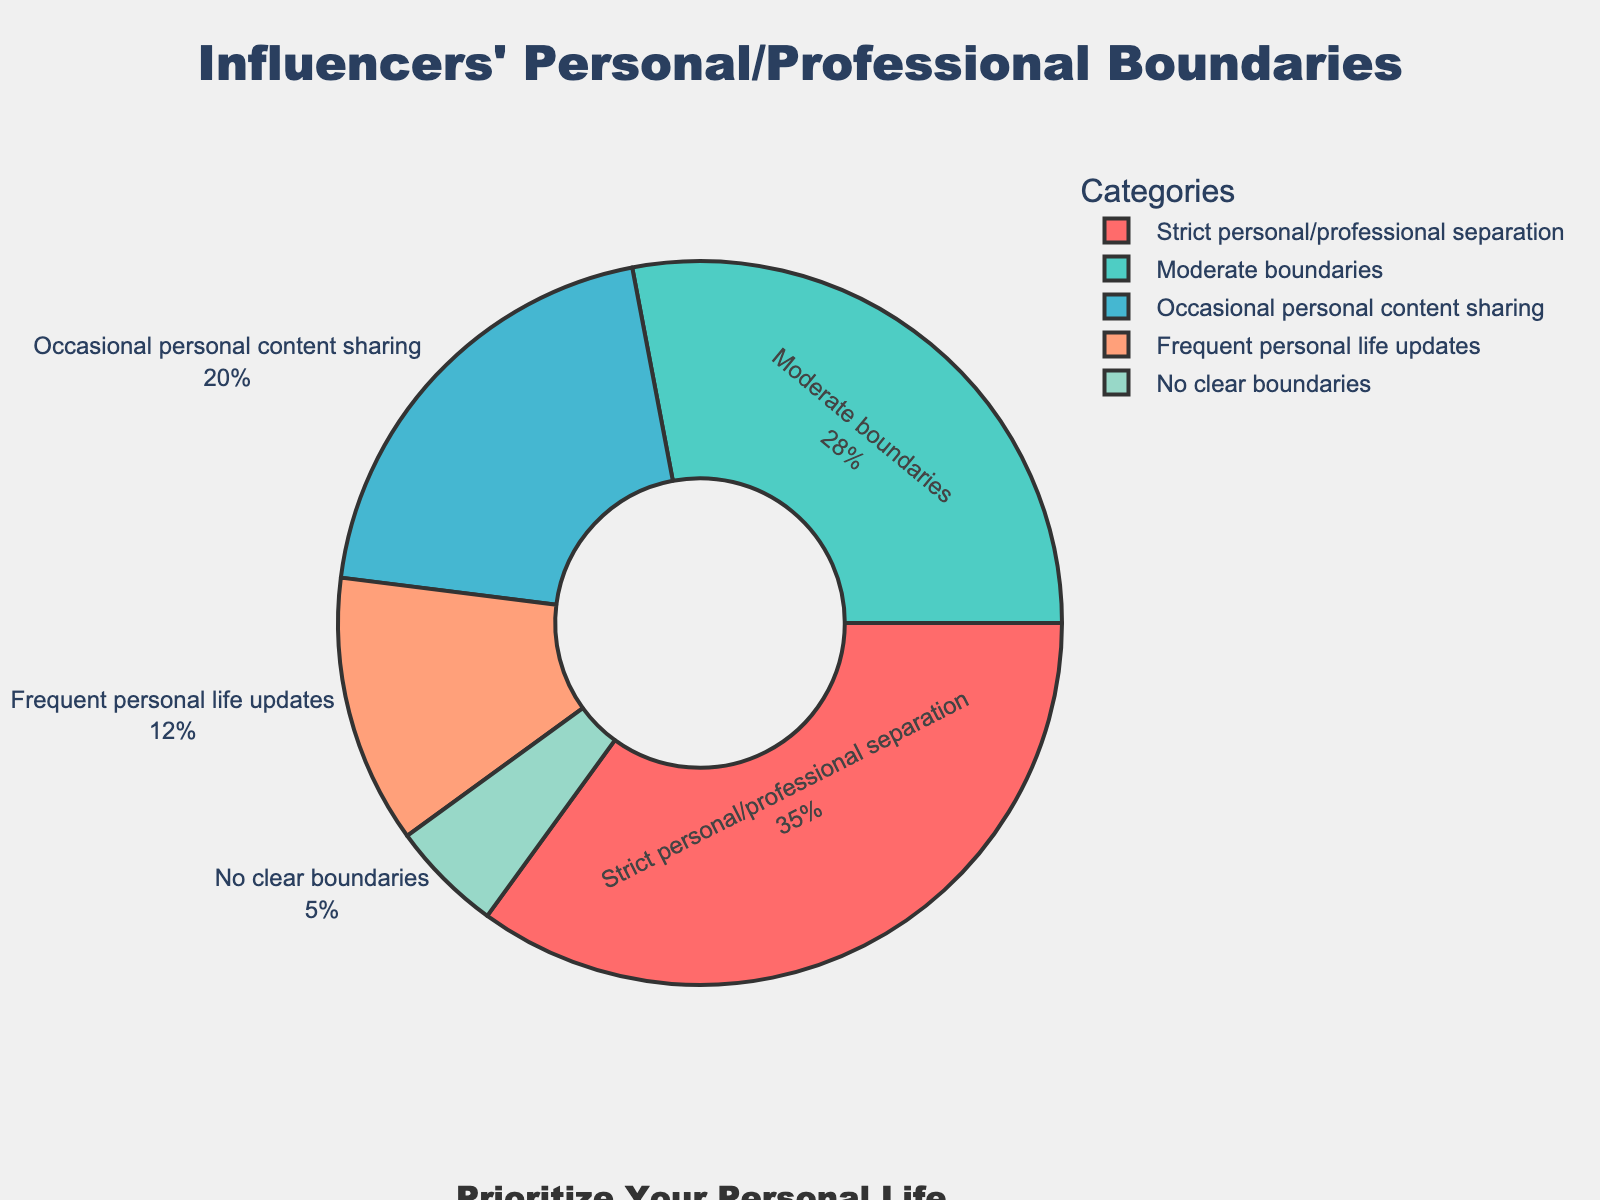What's the most common boundary type among influencers? Look at the section with the largest percentage in the pie chart. The category labeled "Strict personal/professional separation" has the largest section.
Answer: Strict personal/professional separation Which boundary type is least common among influencers? Observe the section with the smallest percentage in the pie chart. The "No clear boundaries" category has the smallest section.
Answer: No clear boundaries How many times more likely are influencers to maintain strict personal/professional separation compared to having no clear boundaries? Look at the percentages of the categories "Strict personal/professional separation" (35%) and "No clear boundaries" (5%). Divide 35 by 5.
Answer: 7 times What percentage of influencers is either occasional or frequent in sharing personal content? Add the percentages for the categories "Occasional personal content sharing" (20%) and "Frequent personal life updates" (12%). 20 + 12 = 32%
Answer: 32% How does the percentage of influencers with moderate boundaries compare to those who share occasional personal content? Refer to the percentages for "Moderate boundaries" (28%) and "Occasional personal content sharing" (20%). Compare these values.
Answer: 28% vs 20% What's the combined percentage of influencers that share some form of personal content, either occasional or frequent? Add the percentages for "Occasional personal content sharing" (20%) and "Frequent personal life updates" (12%). The combined total is 32%.
Answer: 32% If you sum the percentages of influencers who maintain strict or moderate boundaries, what do you get? Add the percentages of "Strict personal/professional separation" (35%) and "Moderate boundaries" (28%). 35 + 28 = 63%
Answer: 63% Which category was represented in a greenish shade in the pie chart? Identify the category colored green. "Moderate boundaries" is depicted in green.
Answer: Moderate boundaries Given that the pie chart rotates from 90 degrees, what position does the "Frequent personal life updates" category start from? Check the visual position starting from the 90-degree marker. The "Frequent personal life updates" category appears to start roughly at this position or shortly after.
Answer: Shortly after 90 degrees How do the visual sizes of the "Moderate boundaries" and "Occasional personal content sharing" sections compare? Compare the visual sizes of these sections in the pie chart. "Moderate boundaries" is larger than "Occasional personal content sharing."
Answer: Moderate boundaries is larger 